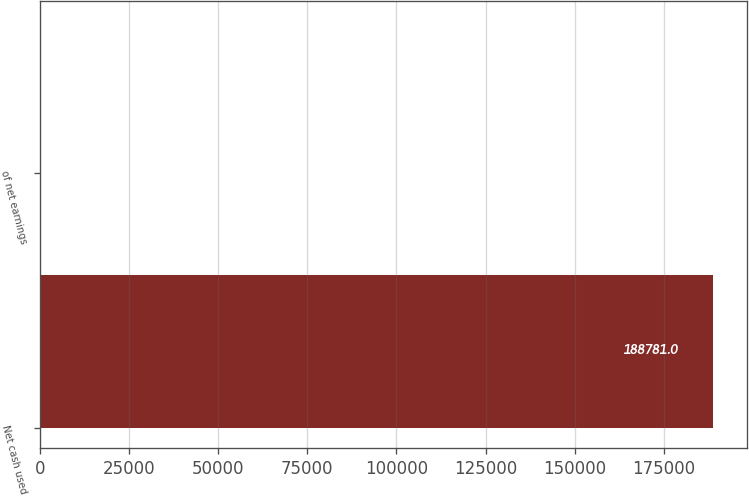Convert chart. <chart><loc_0><loc_0><loc_500><loc_500><bar_chart><fcel>Net cash used<fcel>of net earnings<nl><fcel>188781<fcel>38.2<nl></chart> 